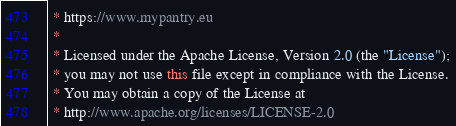<code> <loc_0><loc_0><loc_500><loc_500><_Java_> * https://www.mypantry.eu
 *
 * Licensed under the Apache License, Version 2.0 (the "License");
 * you may not use this file except in compliance with the License.
 * You may obtain a copy of the License at
 * http://www.apache.org/licenses/LICENSE-2.0</code> 